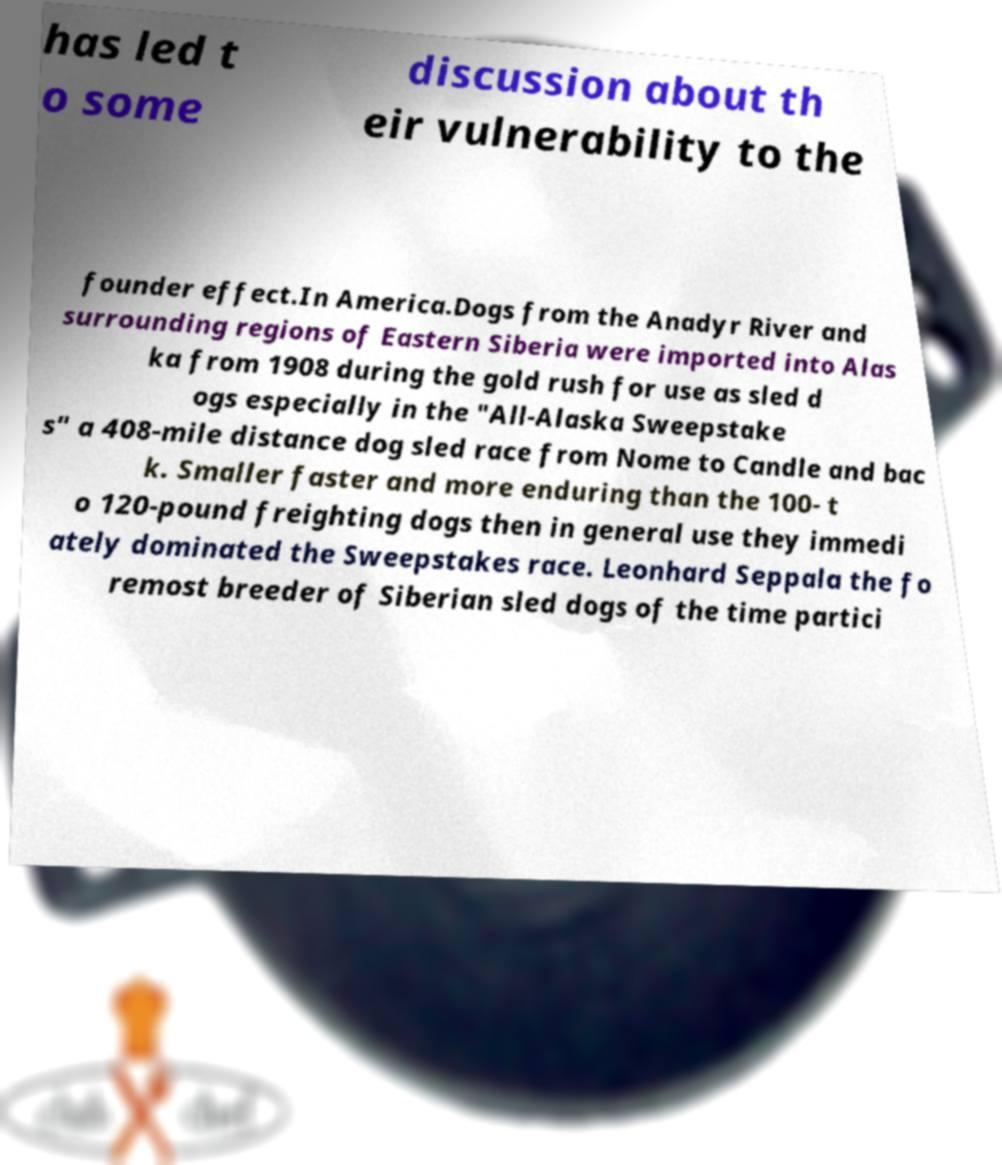For documentation purposes, I need the text within this image transcribed. Could you provide that? has led t o some discussion about th eir vulnerability to the founder effect.In America.Dogs from the Anadyr River and surrounding regions of Eastern Siberia were imported into Alas ka from 1908 during the gold rush for use as sled d ogs especially in the "All-Alaska Sweepstake s" a 408-mile distance dog sled race from Nome to Candle and bac k. Smaller faster and more enduring than the 100- t o 120-pound freighting dogs then in general use they immedi ately dominated the Sweepstakes race. Leonhard Seppala the fo remost breeder of Siberian sled dogs of the time partici 